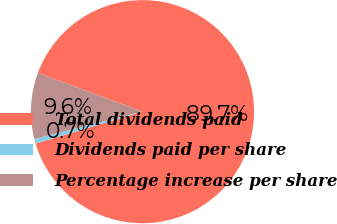Convert chart. <chart><loc_0><loc_0><loc_500><loc_500><pie_chart><fcel>Total dividends paid<fcel>Dividends paid per share<fcel>Percentage increase per share<nl><fcel>89.74%<fcel>0.68%<fcel>9.58%<nl></chart> 